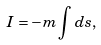<formula> <loc_0><loc_0><loc_500><loc_500>I = - m \int d s ,</formula> 